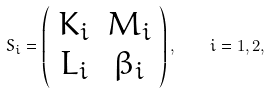Convert formula to latex. <formula><loc_0><loc_0><loc_500><loc_500>S _ { i } = \left ( \begin{array} { c c } K _ { i } & M _ { i } \\ L _ { i } & \beta _ { i } \end{array} \right ) , \quad i = 1 , 2 ,</formula> 